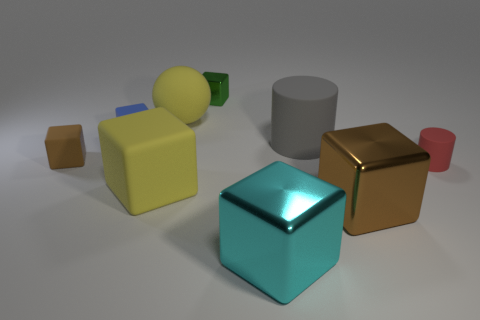What is the material of the block right of the gray rubber object?
Provide a succinct answer. Metal. Do the rubber thing that is to the left of the blue matte cube and the green metal object have the same shape?
Keep it short and to the point. Yes. Is there a rubber thing that has the same size as the gray cylinder?
Give a very brief answer. Yes. There is a green shiny thing; is it the same shape as the tiny matte thing that is on the right side of the green metal cube?
Offer a very short reply. No. The matte object that is the same color as the sphere is what shape?
Your answer should be compact. Cube. Is the number of brown metal cubes to the left of the small blue thing less than the number of large gray rubber things?
Make the answer very short. Yes. Do the red object and the gray rubber thing have the same shape?
Ensure brevity in your answer.  Yes. What is the size of the gray thing that is the same material as the large yellow block?
Ensure brevity in your answer.  Large. Is the number of big balls less than the number of big purple things?
Give a very brief answer. No. How many large objects are either brown matte cubes or green metallic things?
Ensure brevity in your answer.  0. 